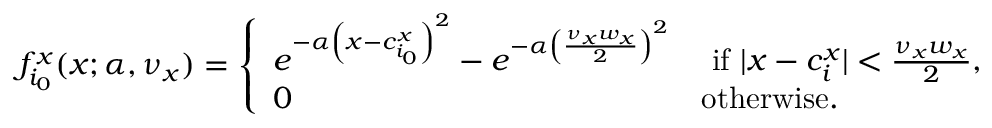Convert formula to latex. <formula><loc_0><loc_0><loc_500><loc_500>f _ { i _ { 0 } } ^ { x } ( x ; \alpha , \nu _ { x } ) = \left \{ \begin{array} { l l } { e ^ { - \alpha \left ( x - c _ { i _ { 0 } } ^ { x } \right ) ^ { 2 } } - e ^ { - \alpha \left ( \frac { \nu _ { x } w _ { x } } { 2 } \right ) ^ { 2 } } } & { i f | x - c _ { i } ^ { x } | < \frac { \nu _ { x } w _ { x } } { 2 } , } \\ { 0 } & { o t h e r w i s e . } \end{array}</formula> 